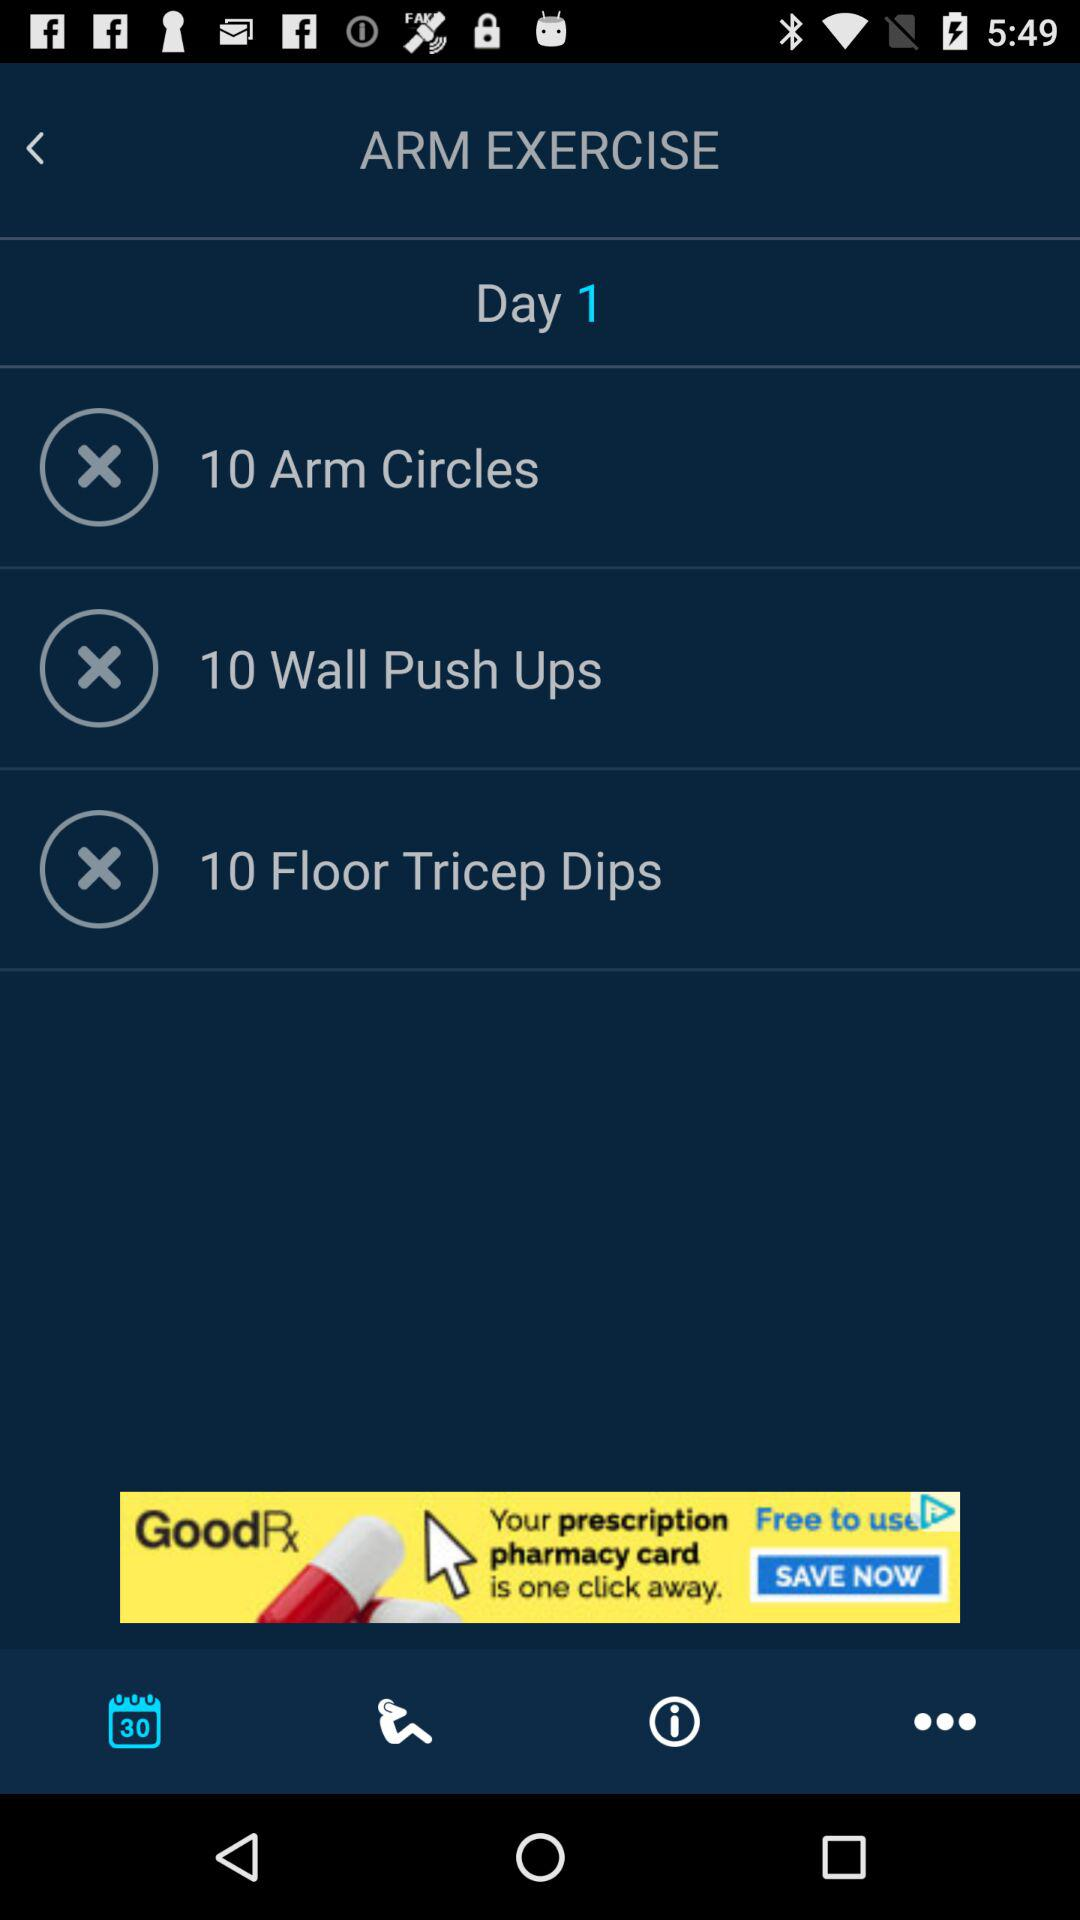How many total exercises are there on this day?
Answer the question using a single word or phrase. 3 